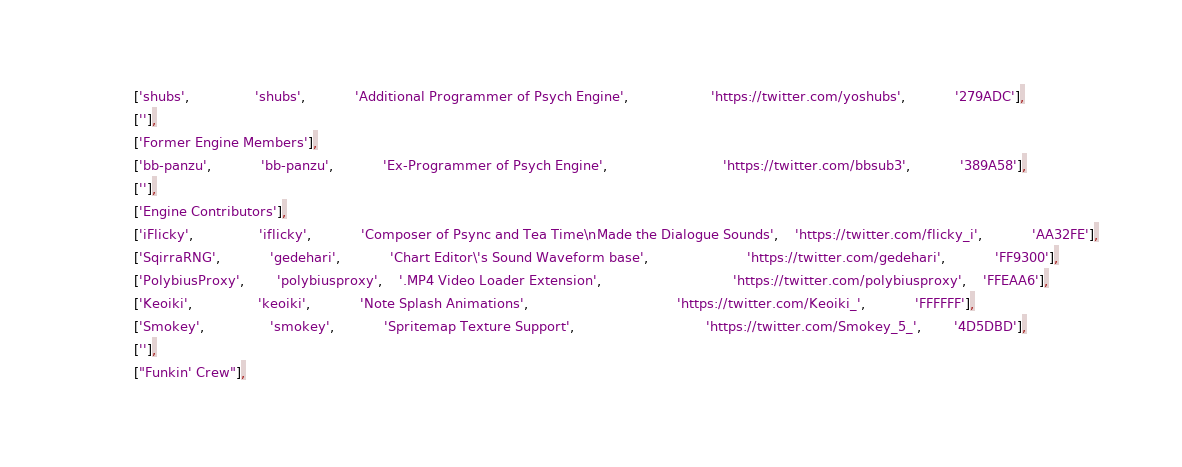<code> <loc_0><loc_0><loc_500><loc_500><_Haxe_>			['shubs',				'shubs',			'Additional Programmer of Psych Engine',					'https://twitter.com/yoshubs',			'279ADC'],
			[''],
			['Former Engine Members'],
			['bb-panzu',			'bb-panzu',			'Ex-Programmer of Psych Engine',							'https://twitter.com/bbsub3',			'389A58'],
			[''],
			['Engine Contributors'],
			['iFlicky',				'iflicky',			'Composer of Psync and Tea Time\nMade the Dialogue Sounds',	'https://twitter.com/flicky_i',			'AA32FE'],
			['SqirraRNG',			'gedehari',			'Chart Editor\'s Sound Waveform base',						'https://twitter.com/gedehari',			'FF9300'],
			['PolybiusProxy',		'polybiusproxy',	'.MP4 Video Loader Extension',								'https://twitter.com/polybiusproxy',	'FFEAA6'],
			['Keoiki',				'keoiki',			'Note Splash Animations',									'https://twitter.com/Keoiki_',			'FFFFFF'],
			['Smokey',				'smokey',			'Spritemap Texture Support',								'https://twitter.com/Smokey_5_',		'4D5DBD'],
			[''],
			["Funkin' Crew"],</code> 